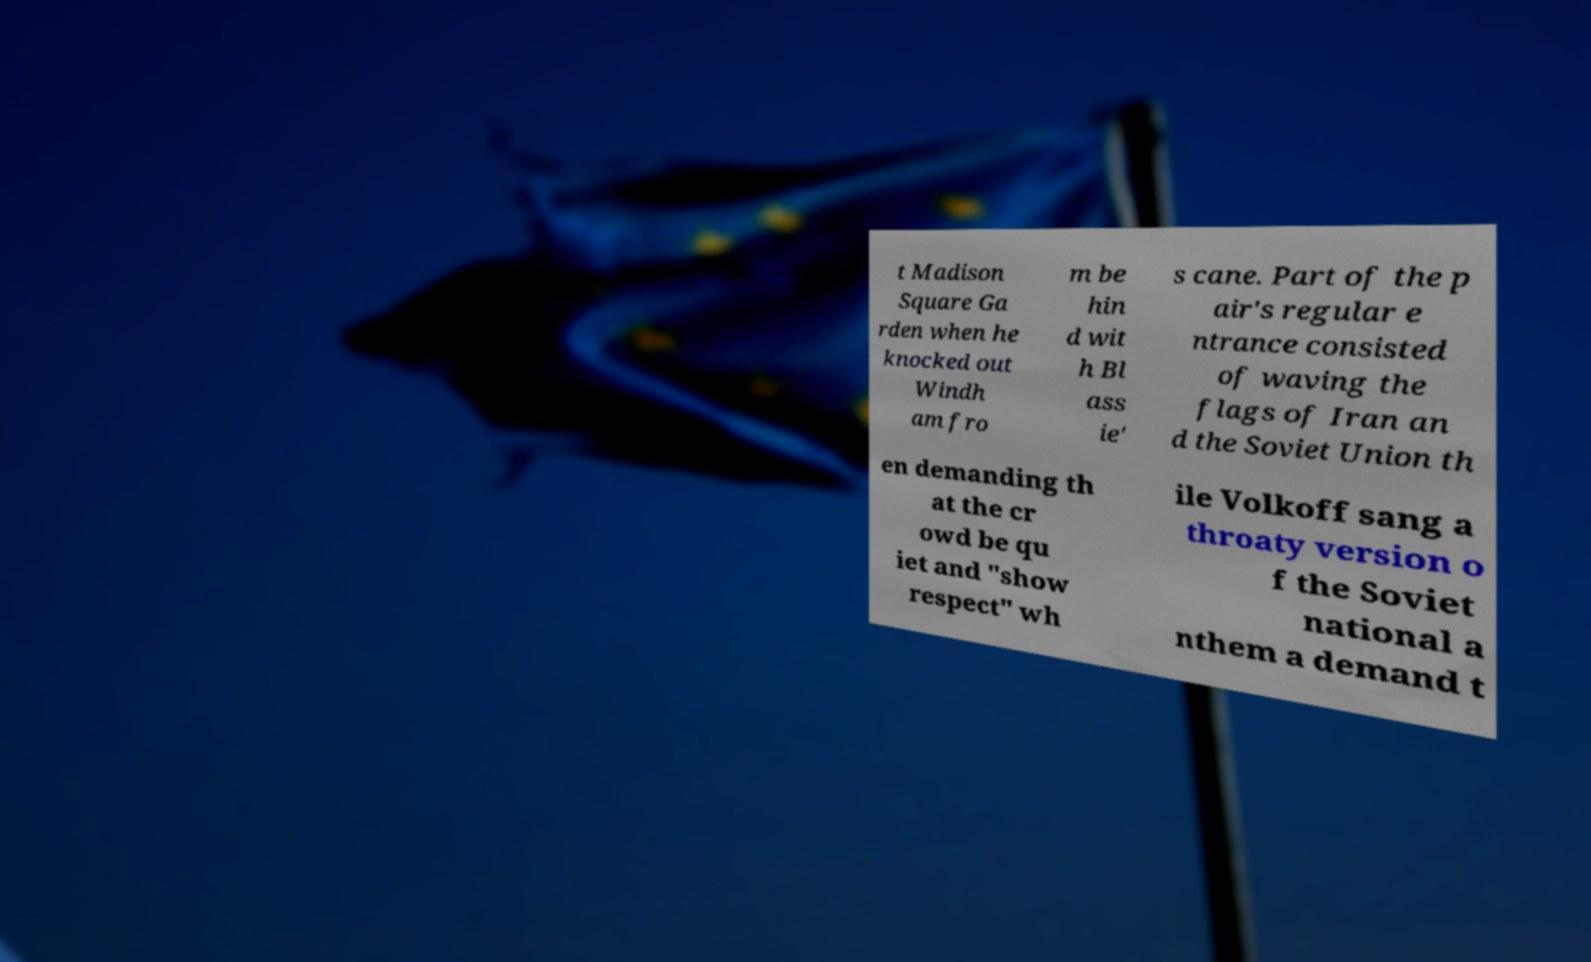There's text embedded in this image that I need extracted. Can you transcribe it verbatim? t Madison Square Ga rden when he knocked out Windh am fro m be hin d wit h Bl ass ie' s cane. Part of the p air's regular e ntrance consisted of waving the flags of Iran an d the Soviet Union th en demanding th at the cr owd be qu iet and "show respect" wh ile Volkoff sang a throaty version o f the Soviet national a nthem a demand t 